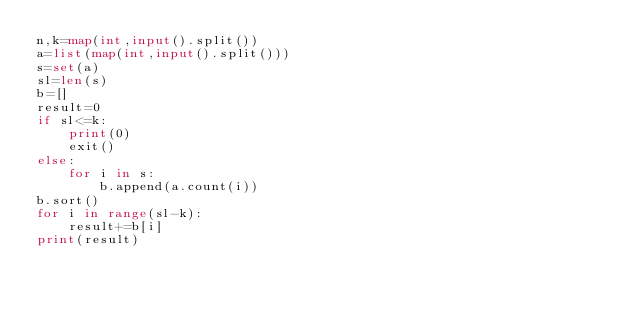<code> <loc_0><loc_0><loc_500><loc_500><_Python_>n,k=map(int,input().split())
a=list(map(int,input().split()))
s=set(a)
sl=len(s)
b=[]
result=0
if sl<=k:
    print(0)
    exit()
else:
    for i in s:
        b.append(a.count(i))
b.sort()
for i in range(sl-k):
    result+=b[i]
print(result)</code> 